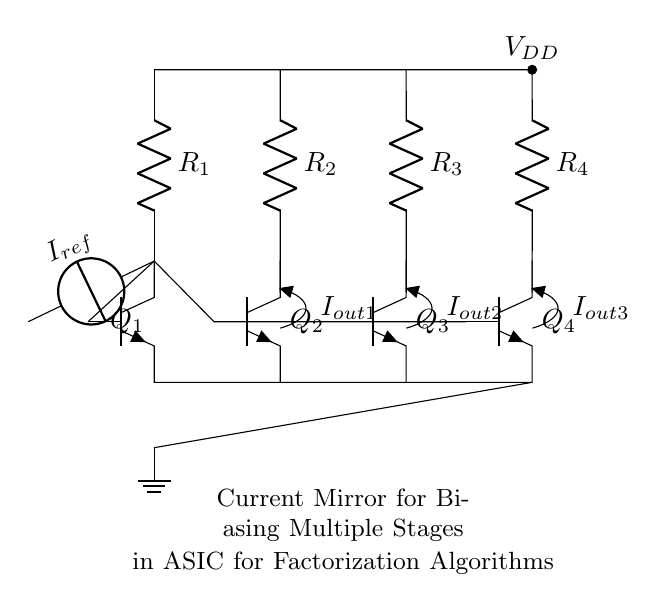What are the components used in this circuit? The circuit consists of four NPN transistors (Q1, Q2, Q3, Q4), four resistors (R1, R2, R3, R4), an input current source (I_ref), and a power supply (V_DD).
Answer: NPN transistors, resistors, current source, power supply How many output currents are there? The diagram shows three output currents (I_out1, I_out2, I_out3) flowing from the collectors of Q2, Q3, and Q4, respectively.
Answer: Three What is the function of the input current source? The input current source (I_ref) provides a reference current to the circuit, which is mirrored by the transistors to bias the other stages in the design.
Answer: Reference current How are the transistors connected in the circuit? The transistors are connected in a manner where the collector of Q1 is directly connected to the base of Q2, creating a current mirror configuration that extends to Q3 and Q4.
Answer: Collector-emitter configuration What voltage is applied to the upper side of the circuit? The upper side of the circuit is powered by a voltage supply labeled as V_DD, which is connected to the top of each resistor.
Answer: V_DD How does the current mirror maintain current consistency? The current mirror maintains current consistency by using the base-emitter junction of Q1 to set the reference current that is mirrored to the other transistors, relying on their matched characteristics to mirror the output currents reliably.
Answer: By matched characteristics 